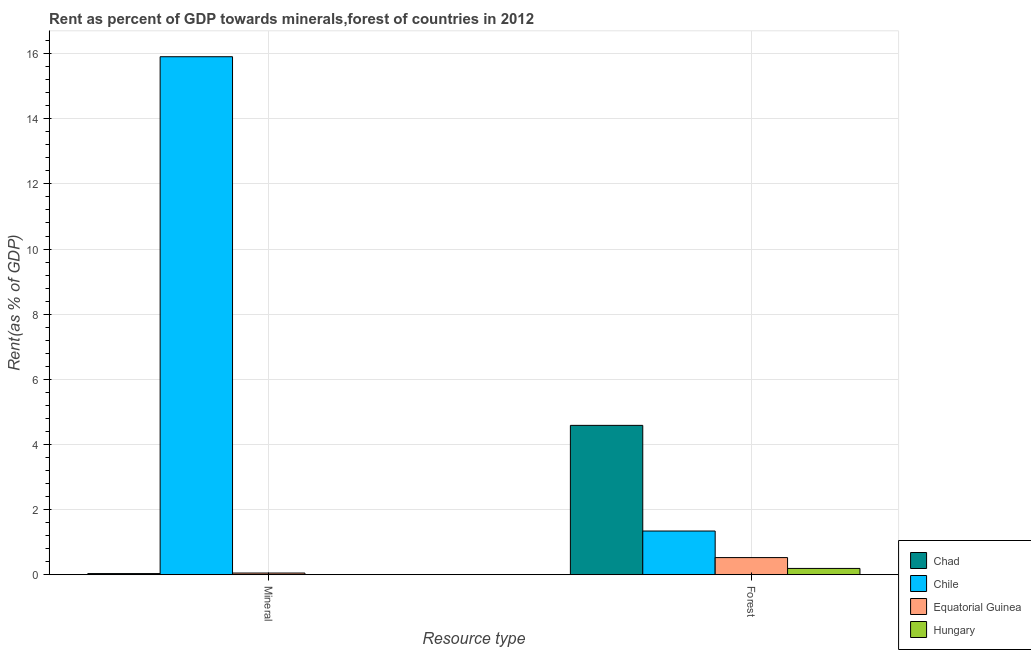How many groups of bars are there?
Provide a short and direct response. 2. Are the number of bars on each tick of the X-axis equal?
Your response must be concise. Yes. How many bars are there on the 1st tick from the left?
Ensure brevity in your answer.  4. How many bars are there on the 2nd tick from the right?
Ensure brevity in your answer.  4. What is the label of the 1st group of bars from the left?
Provide a succinct answer. Mineral. What is the forest rent in Hungary?
Make the answer very short. 0.19. Across all countries, what is the maximum forest rent?
Provide a succinct answer. 4.59. Across all countries, what is the minimum mineral rent?
Ensure brevity in your answer.  0. In which country was the forest rent minimum?
Ensure brevity in your answer.  Hungary. What is the total mineral rent in the graph?
Offer a terse response. 15.99. What is the difference between the mineral rent in Equatorial Guinea and that in Chad?
Provide a short and direct response. 0.02. What is the difference between the forest rent in Equatorial Guinea and the mineral rent in Hungary?
Your response must be concise. 0.52. What is the average forest rent per country?
Your response must be concise. 1.66. What is the difference between the forest rent and mineral rent in Equatorial Guinea?
Provide a succinct answer. 0.47. What is the ratio of the mineral rent in Chad to that in Equatorial Guinea?
Keep it short and to the point. 0.67. Is the mineral rent in Hungary less than that in Chile?
Make the answer very short. Yes. In how many countries, is the mineral rent greater than the average mineral rent taken over all countries?
Your response must be concise. 1. What does the 1st bar from the left in Mineral represents?
Your answer should be compact. Chad. What does the 1st bar from the right in Forest represents?
Ensure brevity in your answer.  Hungary. Are all the bars in the graph horizontal?
Your response must be concise. No. How many countries are there in the graph?
Make the answer very short. 4. What is the difference between two consecutive major ticks on the Y-axis?
Offer a terse response. 2. Where does the legend appear in the graph?
Provide a succinct answer. Bottom right. What is the title of the graph?
Give a very brief answer. Rent as percent of GDP towards minerals,forest of countries in 2012. Does "Upper middle income" appear as one of the legend labels in the graph?
Provide a short and direct response. No. What is the label or title of the X-axis?
Provide a succinct answer. Resource type. What is the label or title of the Y-axis?
Your answer should be very brief. Rent(as % of GDP). What is the Rent(as % of GDP) of Chad in Mineral?
Your answer should be very brief. 0.03. What is the Rent(as % of GDP) of Chile in Mineral?
Provide a short and direct response. 15.91. What is the Rent(as % of GDP) of Equatorial Guinea in Mineral?
Offer a terse response. 0.05. What is the Rent(as % of GDP) of Hungary in Mineral?
Your answer should be compact. 0. What is the Rent(as % of GDP) in Chad in Forest?
Provide a succinct answer. 4.59. What is the Rent(as % of GDP) of Chile in Forest?
Offer a very short reply. 1.34. What is the Rent(as % of GDP) in Equatorial Guinea in Forest?
Make the answer very short. 0.53. What is the Rent(as % of GDP) of Hungary in Forest?
Provide a short and direct response. 0.19. Across all Resource type, what is the maximum Rent(as % of GDP) in Chad?
Offer a terse response. 4.59. Across all Resource type, what is the maximum Rent(as % of GDP) in Chile?
Provide a succinct answer. 15.91. Across all Resource type, what is the maximum Rent(as % of GDP) in Equatorial Guinea?
Your answer should be very brief. 0.53. Across all Resource type, what is the maximum Rent(as % of GDP) of Hungary?
Provide a short and direct response. 0.19. Across all Resource type, what is the minimum Rent(as % of GDP) of Chad?
Keep it short and to the point. 0.03. Across all Resource type, what is the minimum Rent(as % of GDP) in Chile?
Provide a short and direct response. 1.34. Across all Resource type, what is the minimum Rent(as % of GDP) of Equatorial Guinea?
Provide a succinct answer. 0.05. Across all Resource type, what is the minimum Rent(as % of GDP) of Hungary?
Your answer should be very brief. 0. What is the total Rent(as % of GDP) of Chad in the graph?
Provide a short and direct response. 4.62. What is the total Rent(as % of GDP) of Chile in the graph?
Keep it short and to the point. 17.25. What is the total Rent(as % of GDP) in Equatorial Guinea in the graph?
Give a very brief answer. 0.58. What is the total Rent(as % of GDP) of Hungary in the graph?
Your answer should be compact. 0.19. What is the difference between the Rent(as % of GDP) in Chad in Mineral and that in Forest?
Provide a succinct answer. -4.55. What is the difference between the Rent(as % of GDP) in Chile in Mineral and that in Forest?
Provide a succinct answer. 14.56. What is the difference between the Rent(as % of GDP) in Equatorial Guinea in Mineral and that in Forest?
Offer a very short reply. -0.47. What is the difference between the Rent(as % of GDP) of Hungary in Mineral and that in Forest?
Give a very brief answer. -0.19. What is the difference between the Rent(as % of GDP) of Chad in Mineral and the Rent(as % of GDP) of Chile in Forest?
Offer a very short reply. -1.31. What is the difference between the Rent(as % of GDP) in Chad in Mineral and the Rent(as % of GDP) in Equatorial Guinea in Forest?
Ensure brevity in your answer.  -0.49. What is the difference between the Rent(as % of GDP) in Chad in Mineral and the Rent(as % of GDP) in Hungary in Forest?
Offer a terse response. -0.16. What is the difference between the Rent(as % of GDP) in Chile in Mineral and the Rent(as % of GDP) in Equatorial Guinea in Forest?
Offer a terse response. 15.38. What is the difference between the Rent(as % of GDP) in Chile in Mineral and the Rent(as % of GDP) in Hungary in Forest?
Your response must be concise. 15.71. What is the difference between the Rent(as % of GDP) in Equatorial Guinea in Mineral and the Rent(as % of GDP) in Hungary in Forest?
Offer a terse response. -0.14. What is the average Rent(as % of GDP) of Chad per Resource type?
Offer a very short reply. 2.31. What is the average Rent(as % of GDP) in Chile per Resource type?
Ensure brevity in your answer.  8.62. What is the average Rent(as % of GDP) in Equatorial Guinea per Resource type?
Provide a short and direct response. 0.29. What is the average Rent(as % of GDP) of Hungary per Resource type?
Offer a terse response. 0.1. What is the difference between the Rent(as % of GDP) of Chad and Rent(as % of GDP) of Chile in Mineral?
Provide a succinct answer. -15.87. What is the difference between the Rent(as % of GDP) of Chad and Rent(as % of GDP) of Equatorial Guinea in Mineral?
Provide a short and direct response. -0.02. What is the difference between the Rent(as % of GDP) in Chad and Rent(as % of GDP) in Hungary in Mineral?
Your response must be concise. 0.03. What is the difference between the Rent(as % of GDP) of Chile and Rent(as % of GDP) of Equatorial Guinea in Mineral?
Your answer should be very brief. 15.86. What is the difference between the Rent(as % of GDP) in Chile and Rent(as % of GDP) in Hungary in Mineral?
Your response must be concise. 15.91. What is the difference between the Rent(as % of GDP) of Equatorial Guinea and Rent(as % of GDP) of Hungary in Mineral?
Ensure brevity in your answer.  0.05. What is the difference between the Rent(as % of GDP) of Chad and Rent(as % of GDP) of Chile in Forest?
Offer a very short reply. 3.24. What is the difference between the Rent(as % of GDP) of Chad and Rent(as % of GDP) of Equatorial Guinea in Forest?
Ensure brevity in your answer.  4.06. What is the difference between the Rent(as % of GDP) in Chad and Rent(as % of GDP) in Hungary in Forest?
Give a very brief answer. 4.39. What is the difference between the Rent(as % of GDP) of Chile and Rent(as % of GDP) of Equatorial Guinea in Forest?
Your answer should be compact. 0.82. What is the difference between the Rent(as % of GDP) in Chile and Rent(as % of GDP) in Hungary in Forest?
Your answer should be very brief. 1.15. What is the difference between the Rent(as % of GDP) of Equatorial Guinea and Rent(as % of GDP) of Hungary in Forest?
Provide a short and direct response. 0.33. What is the ratio of the Rent(as % of GDP) of Chad in Mineral to that in Forest?
Offer a terse response. 0.01. What is the ratio of the Rent(as % of GDP) of Chile in Mineral to that in Forest?
Your response must be concise. 11.86. What is the ratio of the Rent(as % of GDP) of Equatorial Guinea in Mineral to that in Forest?
Your answer should be very brief. 0.1. What is the ratio of the Rent(as % of GDP) of Hungary in Mineral to that in Forest?
Offer a terse response. 0. What is the difference between the highest and the second highest Rent(as % of GDP) of Chad?
Offer a very short reply. 4.55. What is the difference between the highest and the second highest Rent(as % of GDP) in Chile?
Make the answer very short. 14.56. What is the difference between the highest and the second highest Rent(as % of GDP) in Equatorial Guinea?
Keep it short and to the point. 0.47. What is the difference between the highest and the second highest Rent(as % of GDP) in Hungary?
Offer a terse response. 0.19. What is the difference between the highest and the lowest Rent(as % of GDP) of Chad?
Your answer should be very brief. 4.55. What is the difference between the highest and the lowest Rent(as % of GDP) in Chile?
Your answer should be compact. 14.56. What is the difference between the highest and the lowest Rent(as % of GDP) in Equatorial Guinea?
Your response must be concise. 0.47. What is the difference between the highest and the lowest Rent(as % of GDP) of Hungary?
Provide a short and direct response. 0.19. 